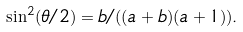Convert formula to latex. <formula><loc_0><loc_0><loc_500><loc_500>\sin ^ { 2 } ( \theta / 2 ) = b / ( ( a + b ) ( a + 1 ) ) .</formula> 